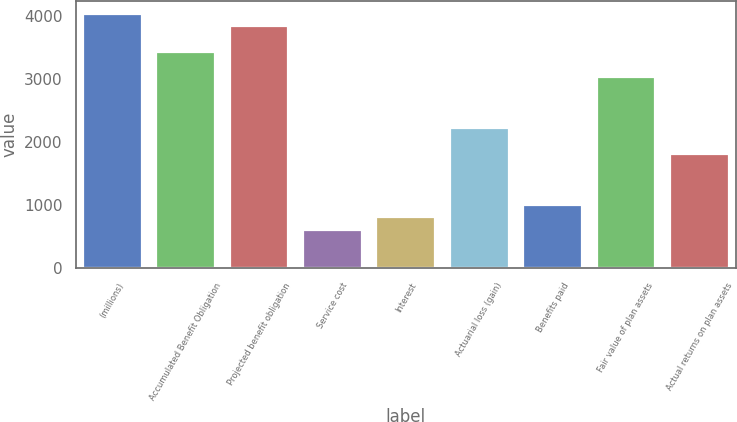Convert chart to OTSL. <chart><loc_0><loc_0><loc_500><loc_500><bar_chart><fcel>(millions)<fcel>Accumulated Benefit Obligation<fcel>Projected benefit obligation<fcel>Service cost<fcel>Interest<fcel>Actuarial loss (gain)<fcel>Benefits paid<fcel>Fair value of plan assets<fcel>Actual returns on plan assets<nl><fcel>4031.2<fcel>3426.64<fcel>3829.68<fcel>605.36<fcel>806.88<fcel>2217.52<fcel>1008.4<fcel>3023.6<fcel>1814.48<nl></chart> 